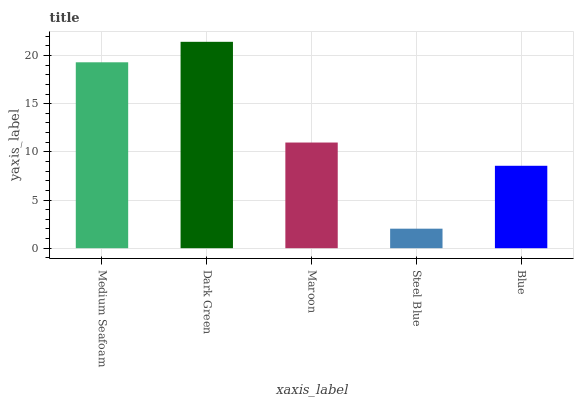Is Steel Blue the minimum?
Answer yes or no. Yes. Is Dark Green the maximum?
Answer yes or no. Yes. Is Maroon the minimum?
Answer yes or no. No. Is Maroon the maximum?
Answer yes or no. No. Is Dark Green greater than Maroon?
Answer yes or no. Yes. Is Maroon less than Dark Green?
Answer yes or no. Yes. Is Maroon greater than Dark Green?
Answer yes or no. No. Is Dark Green less than Maroon?
Answer yes or no. No. Is Maroon the high median?
Answer yes or no. Yes. Is Maroon the low median?
Answer yes or no. Yes. Is Dark Green the high median?
Answer yes or no. No. Is Steel Blue the low median?
Answer yes or no. No. 